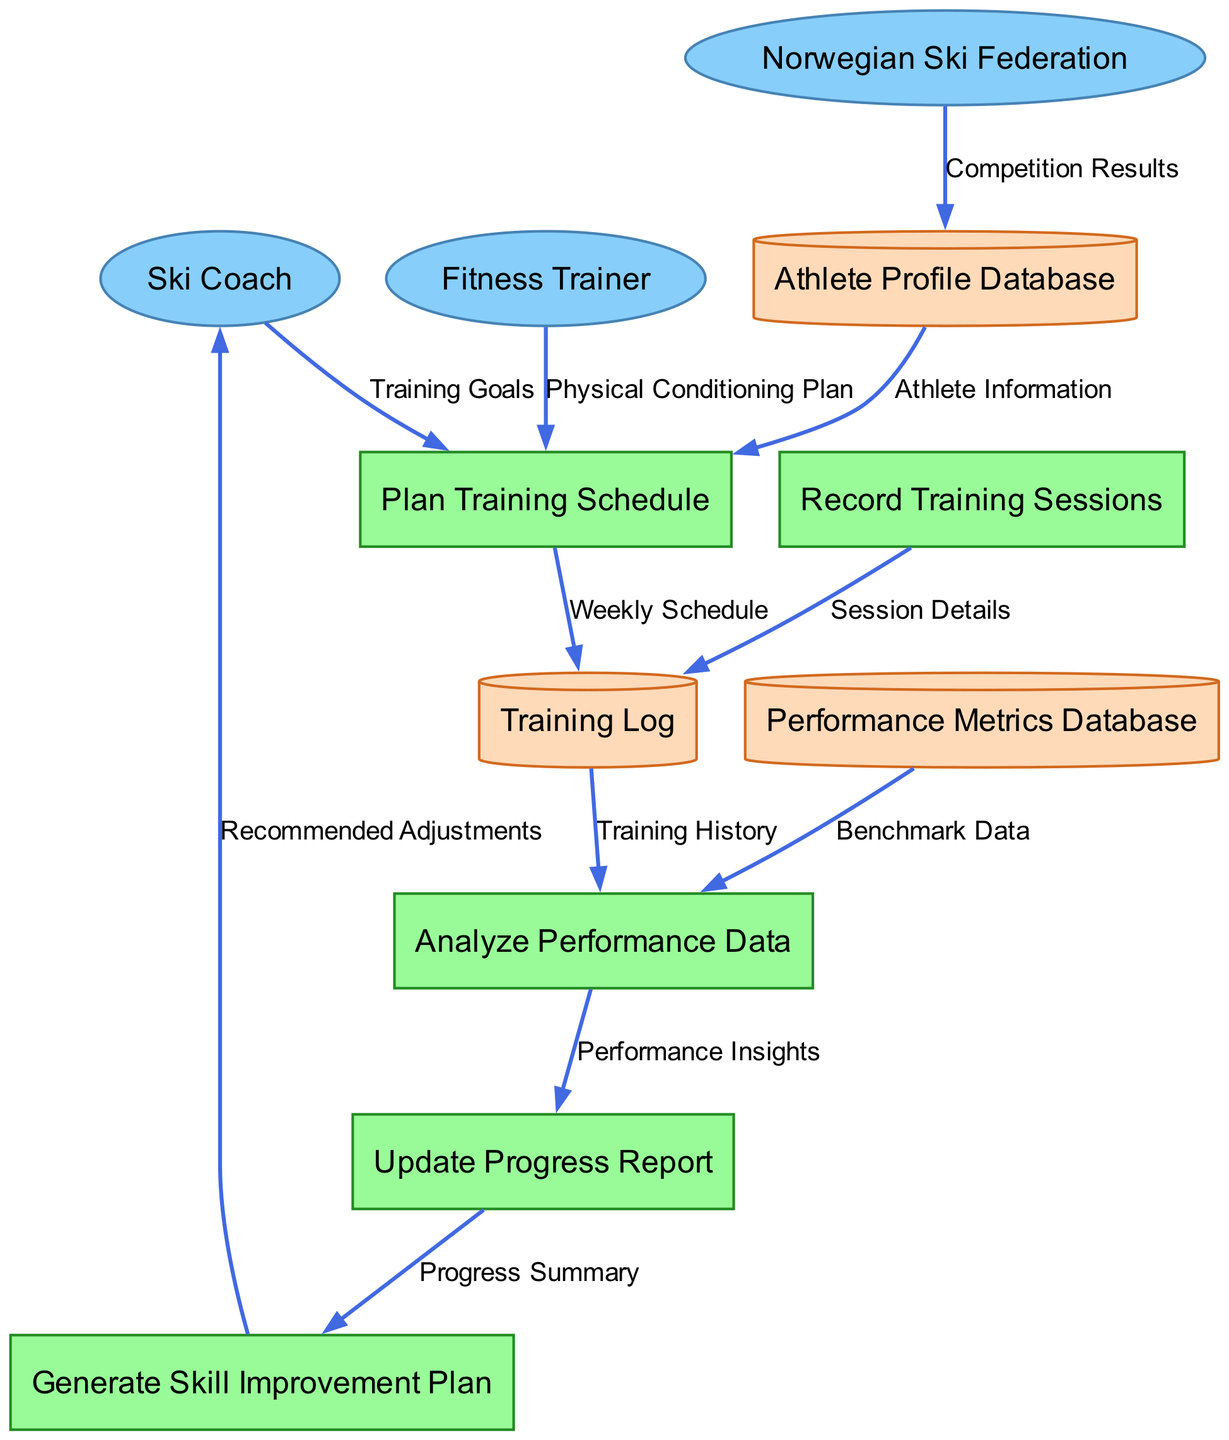What are the external entities in the diagram? The external entities are the people or organizations that interact with the system. In this diagram, they are "Ski Coach," "Fitness Trainer," and "Norwegian Ski Federation."
Answer: Ski Coach, Fitness Trainer, Norwegian Ski Federation How many processes are there in the diagram? The processes represent the activities in the system. There are five processes listed in the diagram: "Plan Training Schedule," "Record Training Sessions," "Analyze Performance Data," "Update Progress Report," and "Generate Skill Improvement Plan."
Answer: 5 What is the data flow from the Fitness Trainer? The data flow from the Fitness Trainer goes to the "Plan Training Schedule" process and is labeled "Physical Conditioning Plan."
Answer: Physical Conditioning Plan Which data store is connected to the "Analyze Performance Data" process? The process "Analyze Performance Data" receives input from the "Training Log" data store, which contains the training history.
Answer: Training Log What does the "Update Progress Report" process output? The "Update Progress Report" process outputs a "Progress Summary" that is sent to the "Generate Skill Improvement Plan" process for further action.
Answer: Progress Summary What type of data does the "Athlete Profile Database" provide to the "Plan Training Schedule"? The "Athlete Profile Database" provides "Athlete Information" to the "Plan Training Schedule" process, which is crucial for tailoring the training plan to the athlete's profile.
Answer: Athlete Information Which process generates recommended adjustments? The process "Generate Skill Improvement Plan" generates the "Recommended Adjustments" that are sent back to the "Ski Coach" for further consideration and action based on the training progress.
Answer: Generate Skill Improvement Plan How many data stores are presented in the diagram? The data stores represent the storage locations for various types of information in the system. There are three data stores: "Athlete Profile Database," "Training Log," and "Performance Metrics Database."
Answer: 3 What is the connection between the "Analyze Performance Data" process and the "Performance Metrics Database"? "Analyze Performance Data" pulls "Benchmark Data" from the "Performance Metrics Database," which is necessary for analyzing the athlete’s performance and comparing it against benchmarks.
Answer: Benchmark Data 